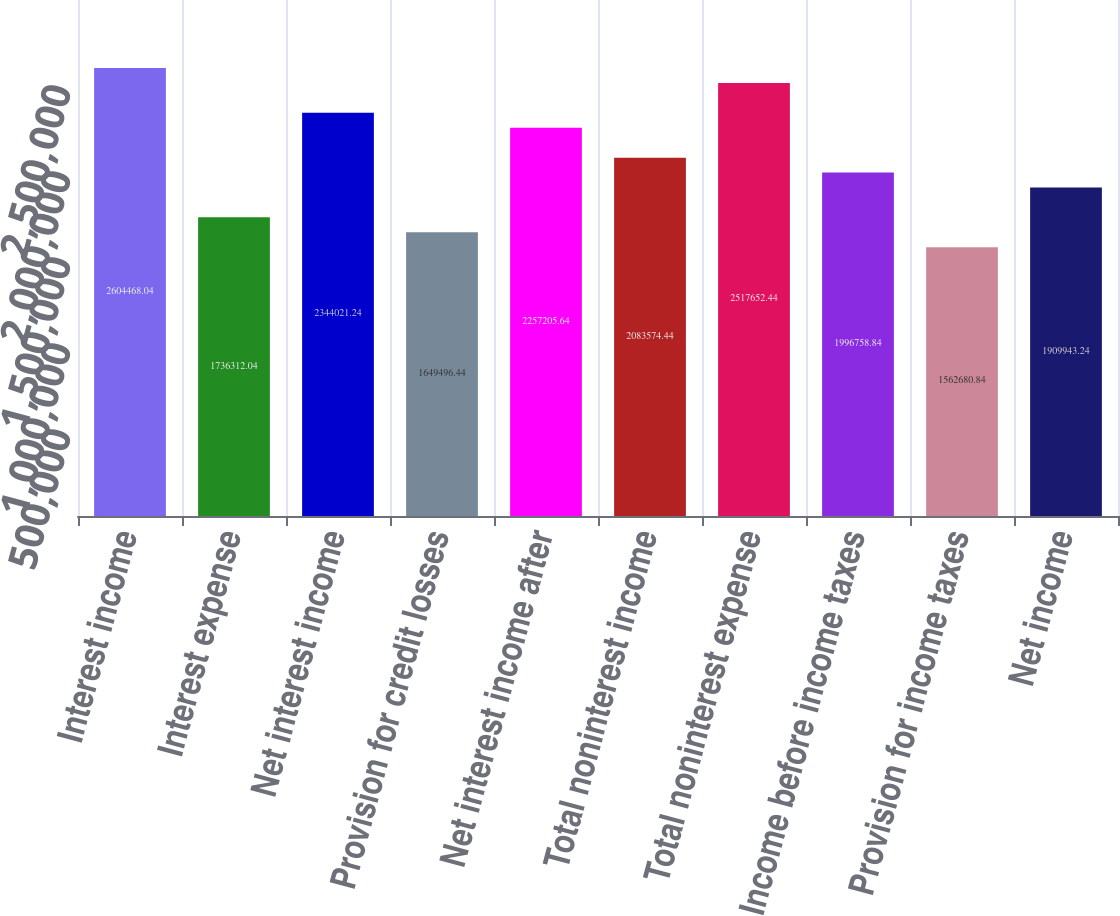<chart> <loc_0><loc_0><loc_500><loc_500><bar_chart><fcel>Interest income<fcel>Interest expense<fcel>Net interest income<fcel>Provision for credit losses<fcel>Net interest income after<fcel>Total noninterest income<fcel>Total noninterest expense<fcel>Income before income taxes<fcel>Provision for income taxes<fcel>Net income<nl><fcel>2.60447e+06<fcel>1.73631e+06<fcel>2.34402e+06<fcel>1.6495e+06<fcel>2.25721e+06<fcel>2.08357e+06<fcel>2.51765e+06<fcel>1.99676e+06<fcel>1.56268e+06<fcel>1.90994e+06<nl></chart> 